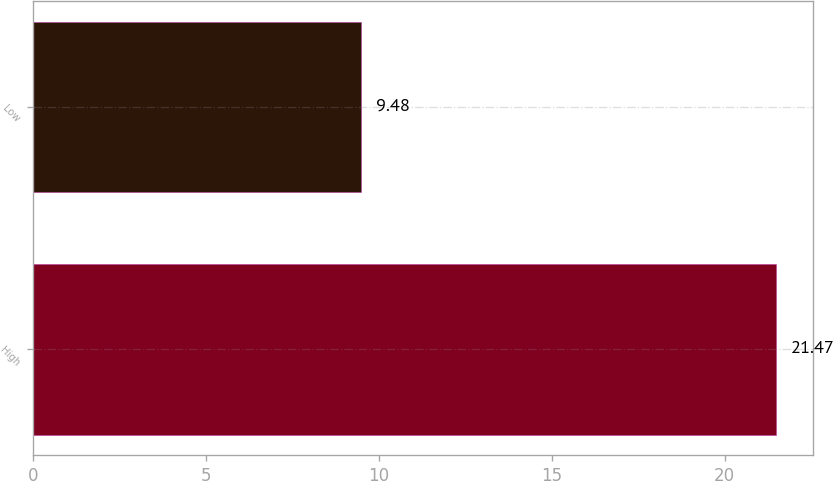<chart> <loc_0><loc_0><loc_500><loc_500><bar_chart><fcel>High<fcel>Low<nl><fcel>21.47<fcel>9.48<nl></chart> 